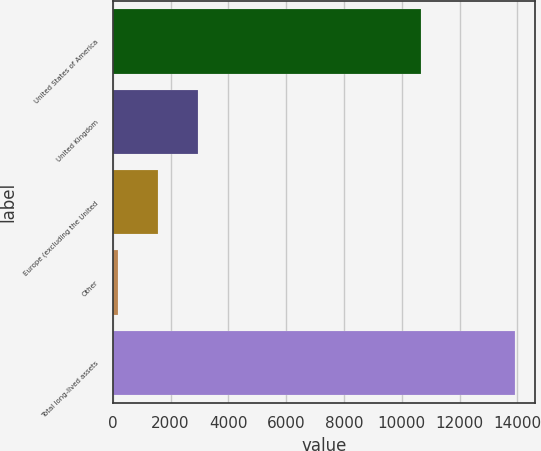Convert chart to OTSL. <chart><loc_0><loc_0><loc_500><loc_500><bar_chart><fcel>United States of America<fcel>United Kingdom<fcel>Europe (excluding the United<fcel>Other<fcel>Total long-lived assets<nl><fcel>10678<fcel>2941.4<fcel>1570.2<fcel>199<fcel>13911<nl></chart> 